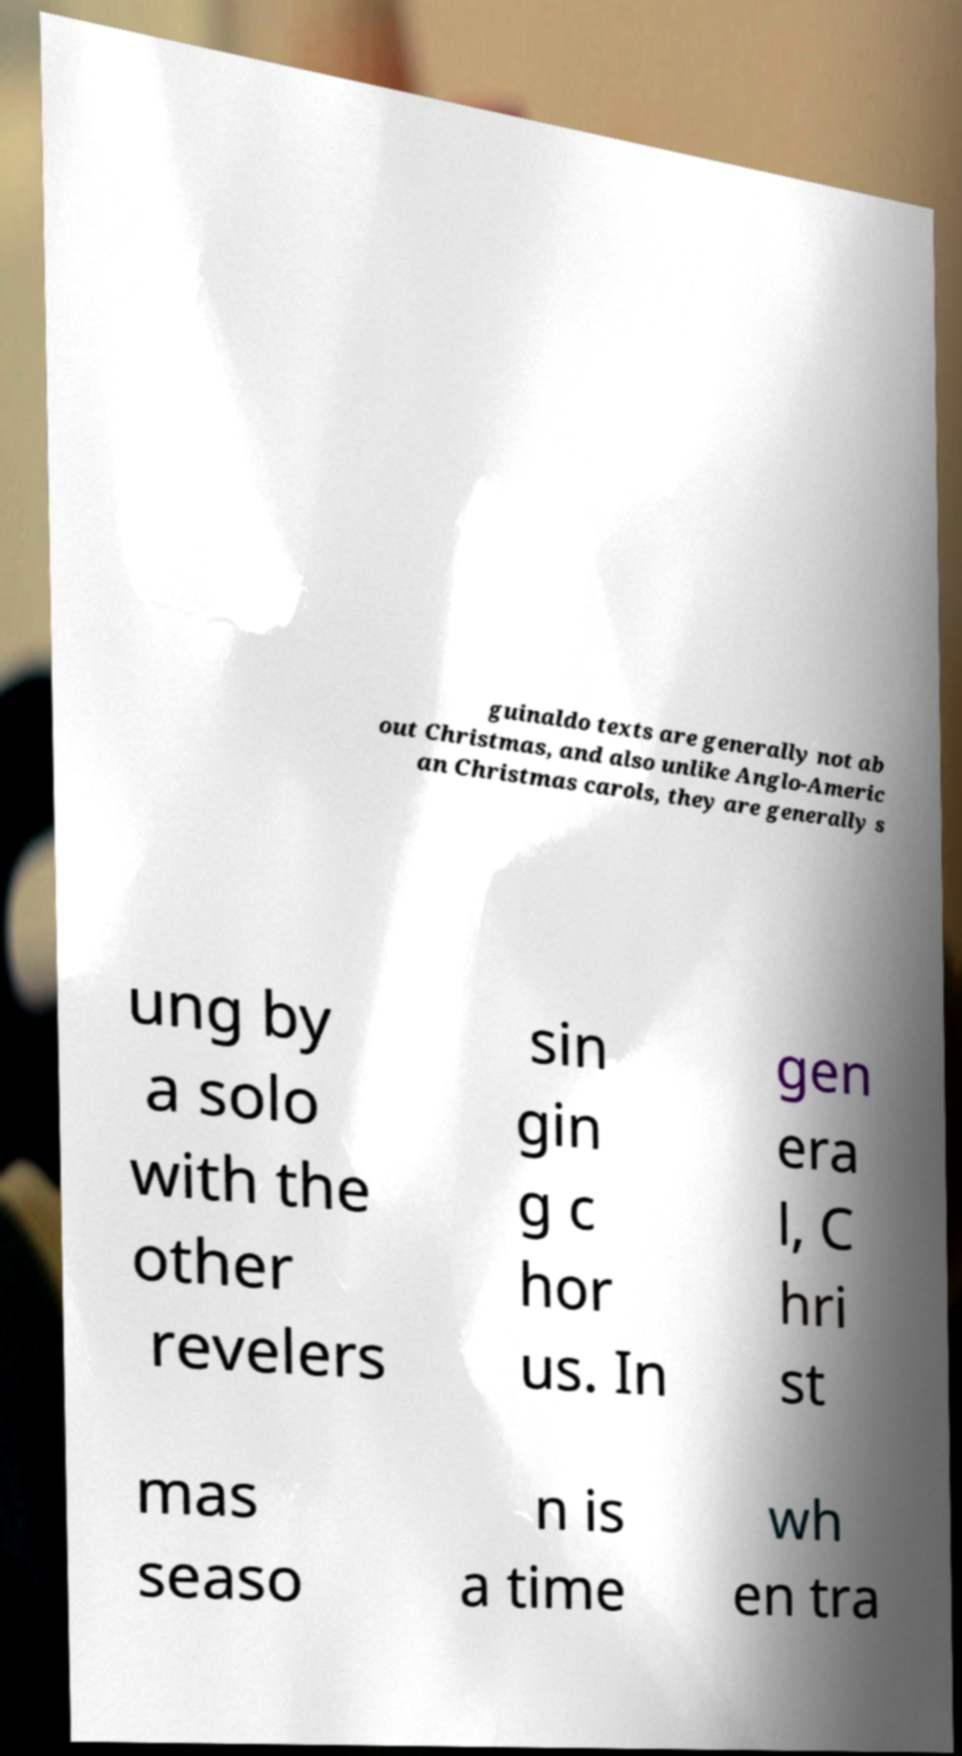There's text embedded in this image that I need extracted. Can you transcribe it verbatim? guinaldo texts are generally not ab out Christmas, and also unlike Anglo-Americ an Christmas carols, they are generally s ung by a solo with the other revelers sin gin g c hor us. In gen era l, C hri st mas seaso n is a time wh en tra 